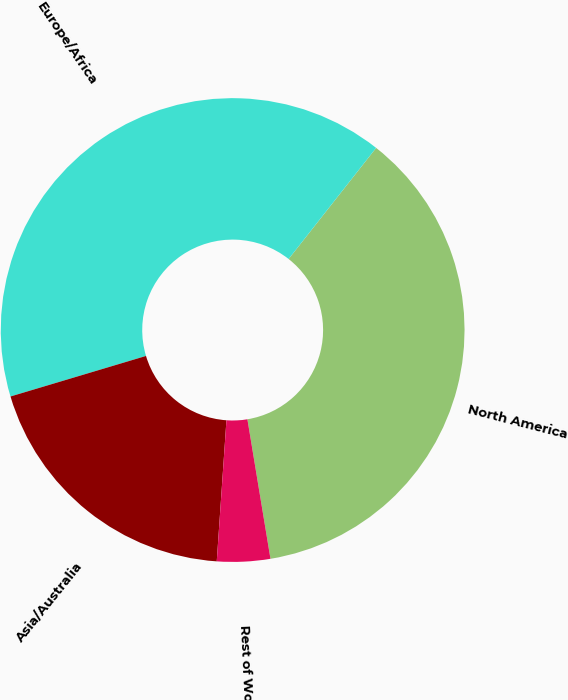Convert chart to OTSL. <chart><loc_0><loc_0><loc_500><loc_500><pie_chart><fcel>North America<fcel>Europe/Africa<fcel>Asia/Australia<fcel>Rest of World<nl><fcel>36.77%<fcel>40.24%<fcel>19.28%<fcel>3.7%<nl></chart> 